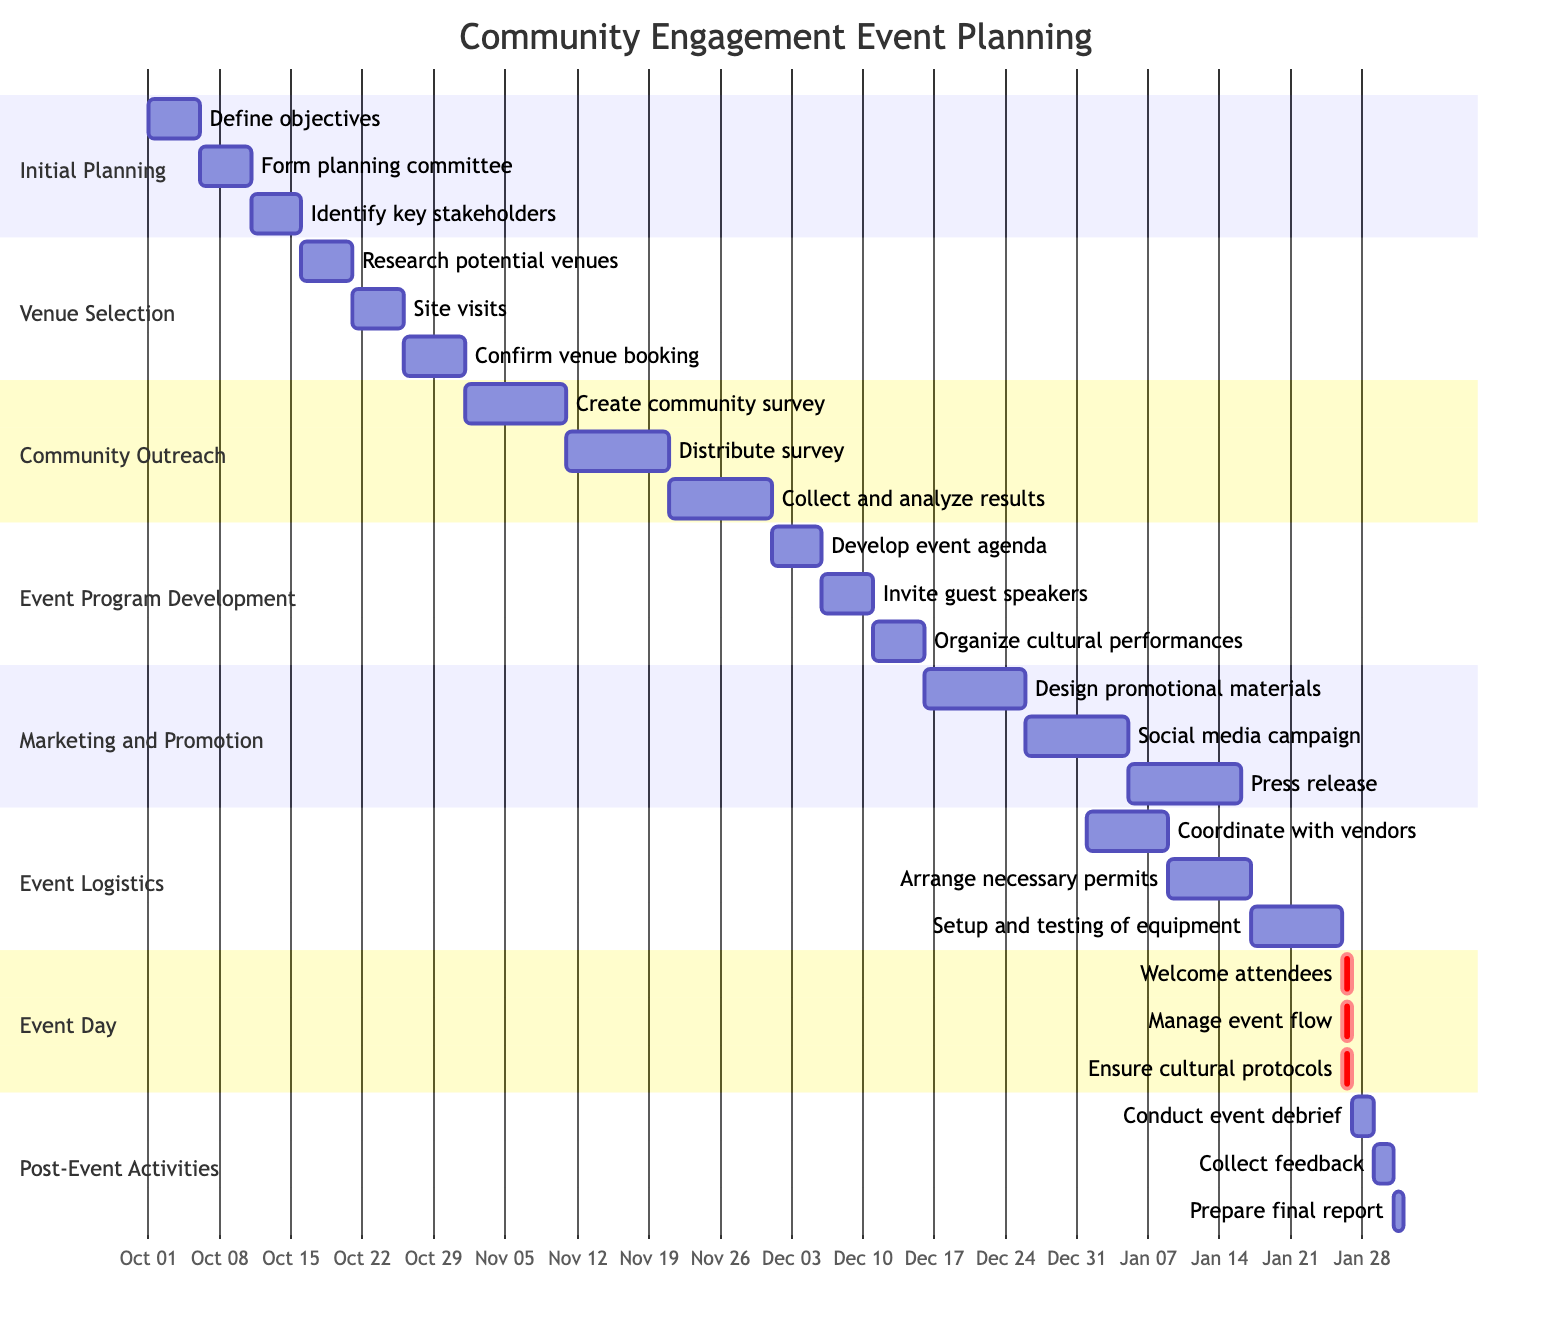What is the start date of the Community Engagement Event Planning? The Gantt chart indicates that the timeline for the Community Engagement Event Planning starts on October 1, 2023.
Answer: October 1, 2023 How many tasks are outlined in the 'Event Day' section? The 'Event Day' section consists of three tasks: Welcome attendees, Manage event flow, and Ensure cultural protocols, indicating that there are three tasks in total.
Answer: 3 Which milestone has the longest duration? By reviewing the milestones in the Gantt chart, 'Marketing and Promotion' spans from December 16, 2023, to January 15, 2024, which totals 30 days, making it the longest duration.
Answer: Marketing and Promotion What is the last task scheduled before the Event Day? The last task before the Event Day is 'Setup and testing of equipment', which occurs from January 17 to January 25, 2024.
Answer: Setup and testing of equipment In which month does the 'Community Outreach' phase begin? The 'Community Outreach' phase starts on November 1, indicating it begins in the month of November.
Answer: November How many days does the 'Initial Planning' section last? The 'Initial Planning' section spans from October 1 to October 15, 2023, lasting a total of 15 days.
Answer: 15 days What are the tasks that occur during the 'Post-Event Activities'? The tasks listed in the 'Post-Event Activities' section include: Conduct event debrief, Collect feedback, and Prepare final report, making it clear what is expected after the event.
Answer: Conduct event debrief, Collect feedback, Prepare final report Which task has the latest start date in the Gantt chart? Reviewing the tasks, 'Press release' starts on January 5, 2024, which is the latest start date among all tasks in the Gantt chart.
Answer: Press release What is the total duration of the 'Event Logistics' phase? The 'Event Logistics' phase runs from January 1 to January 25, 2024, covering a total duration of 25 days from start to end.
Answer: 25 days 